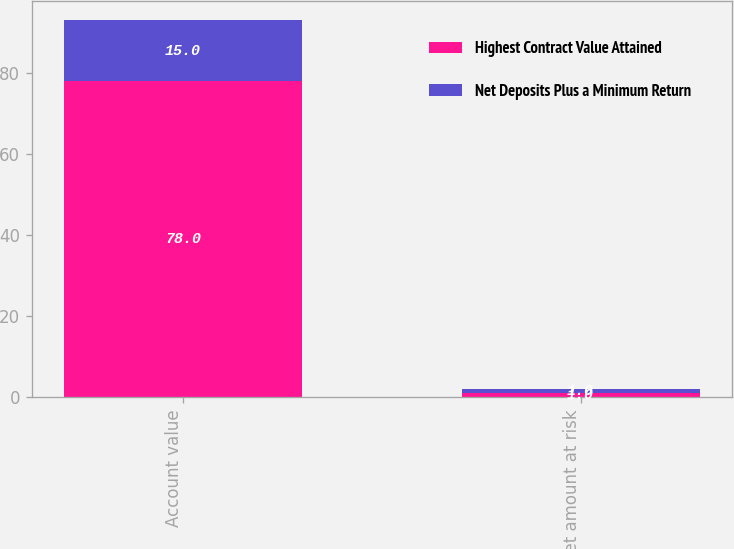Convert chart to OTSL. <chart><loc_0><loc_0><loc_500><loc_500><stacked_bar_chart><ecel><fcel>Account value<fcel>Net amount at risk<nl><fcel>Highest Contract Value Attained<fcel>78<fcel>1<nl><fcel>Net Deposits Plus a Minimum Return<fcel>15<fcel>1<nl></chart> 